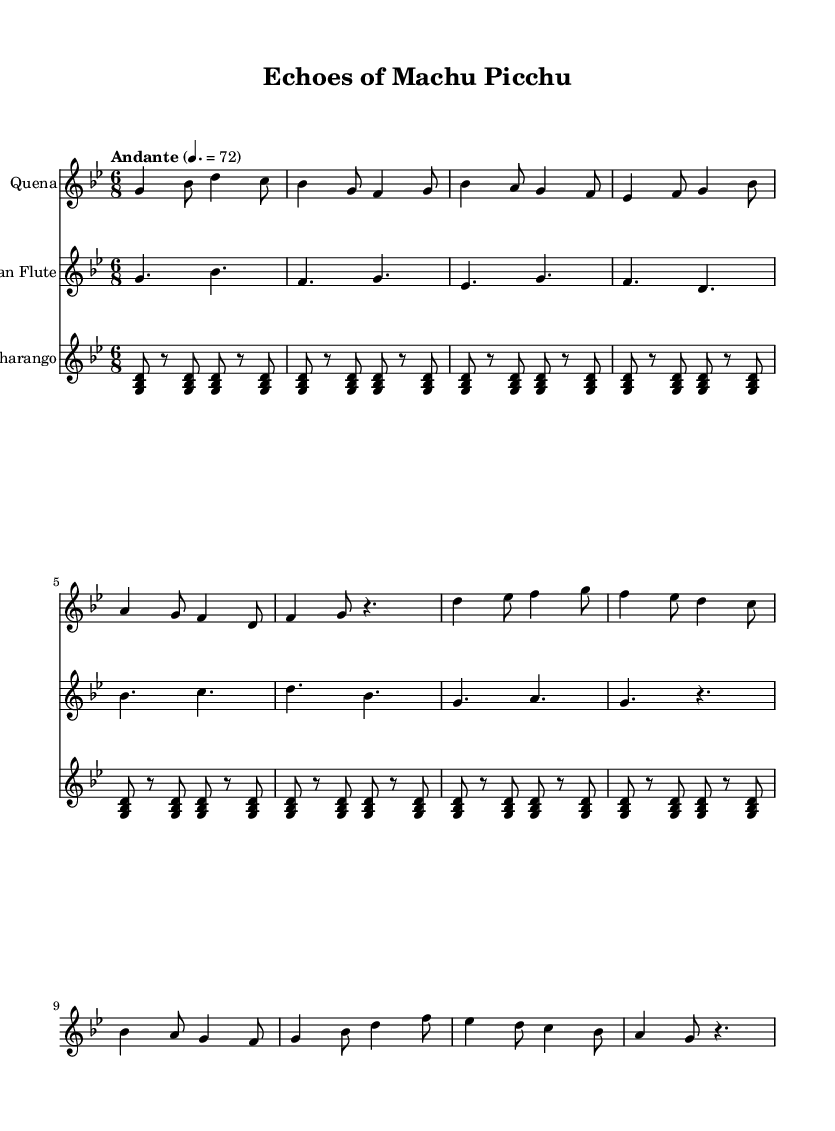What is the key signature of this music? The key signature is indicated at the beginning of the music, showing the notes that are sharp or flat. Here, it shows five flats, which corresponds to G minor.
Answer: G minor What is the time signature of the music? The time signature is displayed at the start of the score indicating how many beats are in each measure and which note value is equivalent to one beat. In this case, the 6/8 time signature indicates there are six eighth notes per measure.
Answer: 6/8 What is the tempo marking for this piece? The tempo marking is given in the score which describes the speed of the music. Here, it states "Andante" at a speed of 72 beats per minute, indicating a moderate walking pace.
Answer: Andante 4. = 72 Which instruments are used in this piece? The instruments are specified at the start of each staff. The score includes three instruments labeled as "Quena," "Pan Flute," and "Charango," indicating the traditional Andean music ensemble.
Answer: Quena, Pan Flute, Charango How many measures are in the main theme for the Quena? By counting the number of measure bars that contain music in the "quena" part, we can determine the number of measures. The sequence provided for the "quena" consists of eight measures.
Answer: 8 What type of scale is likely used in this piece considering its cultural background? Given that this piece is inspired by Andean music, the scale used is likely to feature pentatonic elements, which are common in traditional Andean music. The presence of minor intervals also supports this classification.
Answer: Pentatonic What rhythmic pattern is played by the Charango? The Charango part consists of repeated rhythmic patterns that create a consistent driving force throughout the piece. This rhythmic structure often includes strummed chords in an upbeat manner, representing the syncopated feel typical of Andean music.
Answer: Repeated rhythmic pattern 